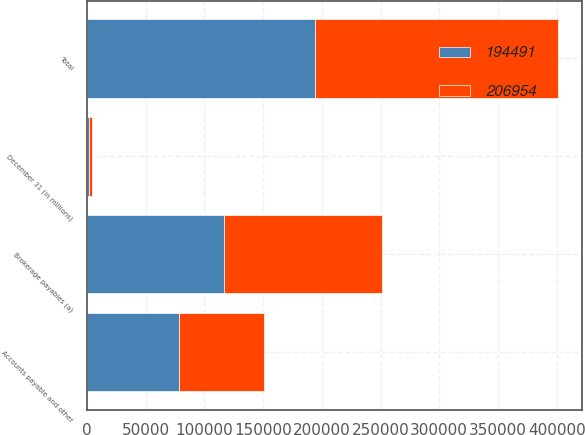Convert chart to OTSL. <chart><loc_0><loc_0><loc_500><loc_500><stacked_bar_chart><ecel><fcel>December 31 (in millions)<fcel>Brokerage payables (a)<fcel>Accounts payable and other<fcel>Total<nl><fcel>206954<fcel>2014<fcel>134467<fcel>72487<fcel>206954<nl><fcel>194491<fcel>2013<fcel>116391<fcel>78100<fcel>194491<nl></chart> 